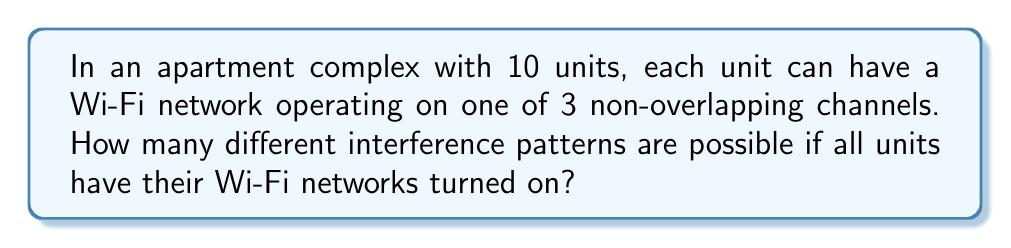Show me your answer to this math problem. Let's approach this step-by-step:

1) Each apartment has 3 choices for its Wi-Fi channel.

2) There are 10 apartments in total.

3) This scenario is a perfect example of the Multiplication Principle in combinatorics. When we have a sequence of independent choices, we multiply the number of possibilities for each choice.

4) In this case, we have 10 independent choices (one for each apartment), and each choice has 3 possibilities.

5) Therefore, the total number of possible interference patterns is:

   $$3 \times 3 \times 3 \times ... \times 3$$ (10 times)

6) This can be written as an exponent:

   $$3^{10}$$

7) Calculating this:
   $$3^{10} = 59,049$$

Thus, there are 59,049 possible interference patterns in this apartment complex.
Answer: $3^{10} = 59,049$ 